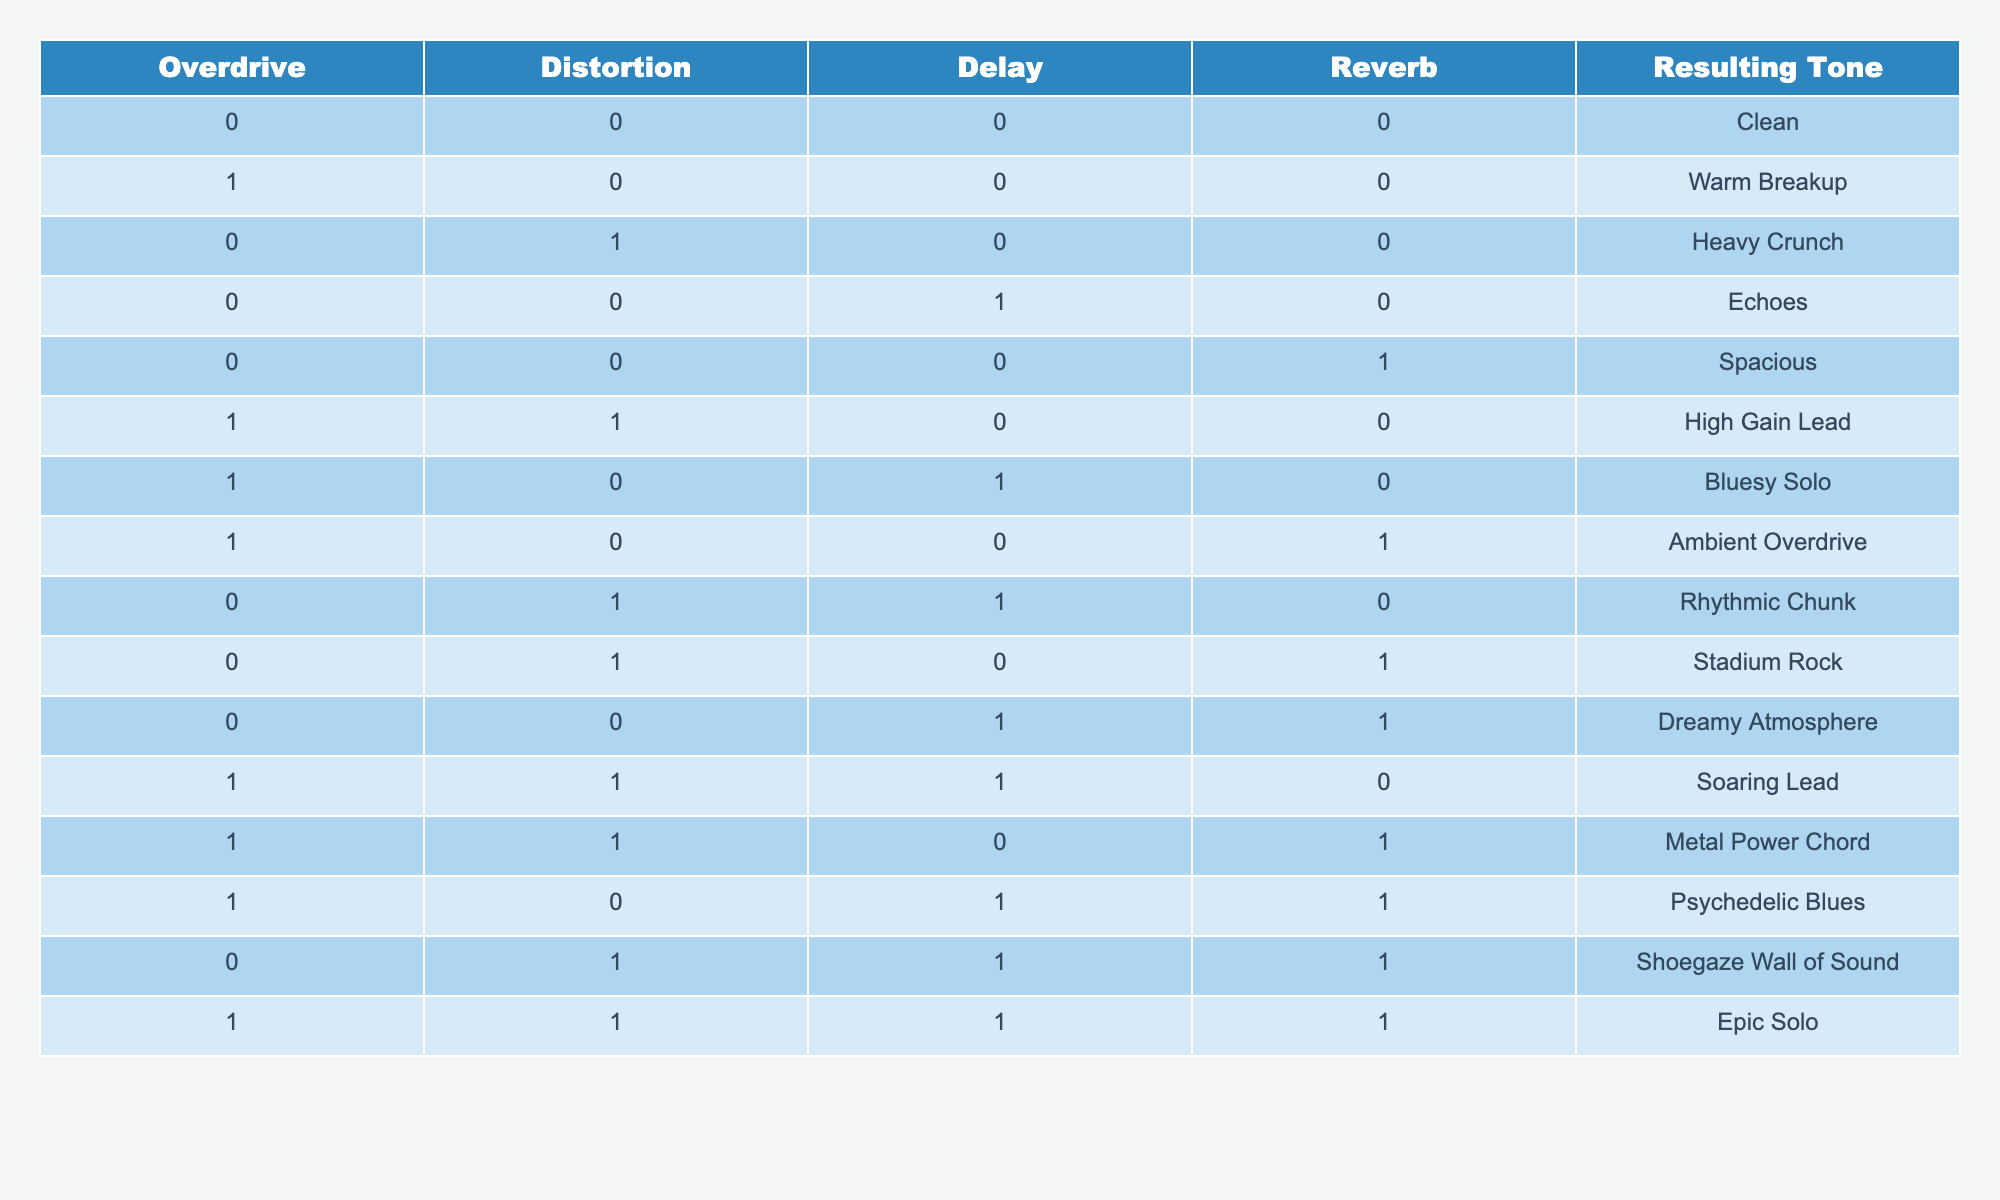What tone results from using only Overdrive? Referring to the table, when Overdrive is set to 1 (active) and all other effects are set to 0, the resulting tone is "Warm Breakup".
Answer: Warm Breakup How many combinations produce a "Heavy Crunch" tone? By examining the table, there is only one combination with Distortion set to 1 and all other effects set to 0, resulting in "Heavy Crunch".
Answer: 1 Is it possible to achieve a "Dreamy Atmosphere" with Distortion turned on? Looking at the table, "Dreamy Atmosphere" results only when all effects are off except Reverb. Therefore, Distortion must be turned off to achieve this tone.
Answer: No What effect combination results in the "Ambient Overdrive" tone? The table shows that "Ambient Overdrive" is achieved when Overdrive is set to 1, Delay is set to 0, and Reverb is set to 1, with Distortion turned off.
Answer: Overdrive 1, Distortion 0, Delay 0, Reverb 1 Which is the only tone that combines all four effects? The table indicates that "Epic Solo" occurs when all four effects are active (Overdrive 1, Distortion 1, Delay 1, Reverb 1). Therefore, this is the only tone resulting from all effects being used.
Answer: Epic Solo If you want a tone that has no Overdrive and generates "Stadium Rock", what other effects do you need? The table specifies "Stadium Rock" is produced with Distortion set to 1 and Reverb set to 1, with Overdrive remaining off. This means both Distortion and Reverb are needed to produce this tone.
Answer: Distortion 1, Reverb 1 What is the resulting tone when Delay is turned on with all other effects off? According to the table, activating Delay while keeping all other effects off results in "Echoes".
Answer: Echoes How does "Soaring Lead" differ from "Metal Power Chord"? "Soaring Lead" has both Overdrive and Distortion activated while keeping Reverb off, and "Metal Power Chord" has all effects on, including Reverb. Thus, the difference is the Reverb effect being on for the "Metal Power Chord".
Answer: Reverb effect differs What is the total number of tones produced with only reverb activated? The table indicates that "Spacious", "Dreamy Atmosphere", and "Shoegaze Wall of Sound" are produced with Reverb on and other effects off. Thus, there are three tones created.
Answer: 3 What combinations produce tones with both Overdrive and Delay active? Examining the table, "Bluesy Solo" (Overdrive 1, Delay 0, Reverb 1) and "Psychedelic Blues" (Overdrive 1, Delay 1, Reverb 1) are the two tones that maintain Overdrive and Delay both active.
Answer: Bluesy Solo, Psychedelic Blues 